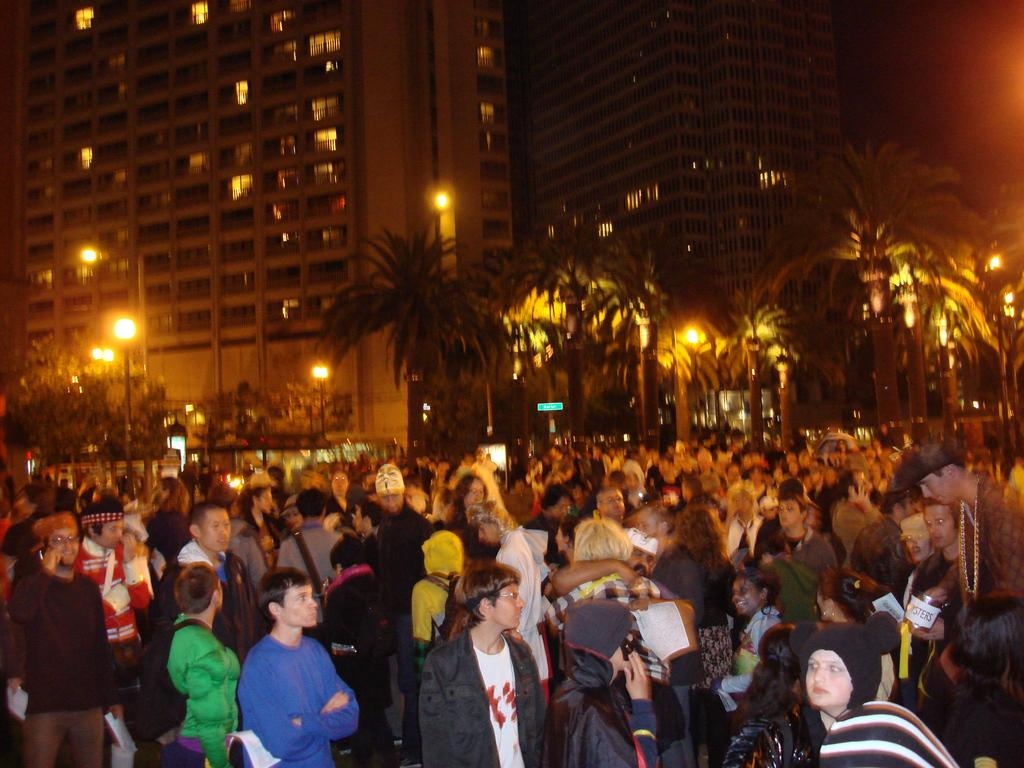What can be seen in the image? There are people standing in the image. What is visible in the background of the image? There is a tree, street lights, and buildings in the background of the image. Are there any lights associated with the buildings in the background? Yes, there are lights associated with the buildings in the background of the image. What type of wound can be seen on the tree in the image? There is no wound visible on the tree in the image, as it appears to be a healthy tree. What type of sail is attached to the people in the image? There is no sail present in the image; the people are standing without any sails or related equipment. 